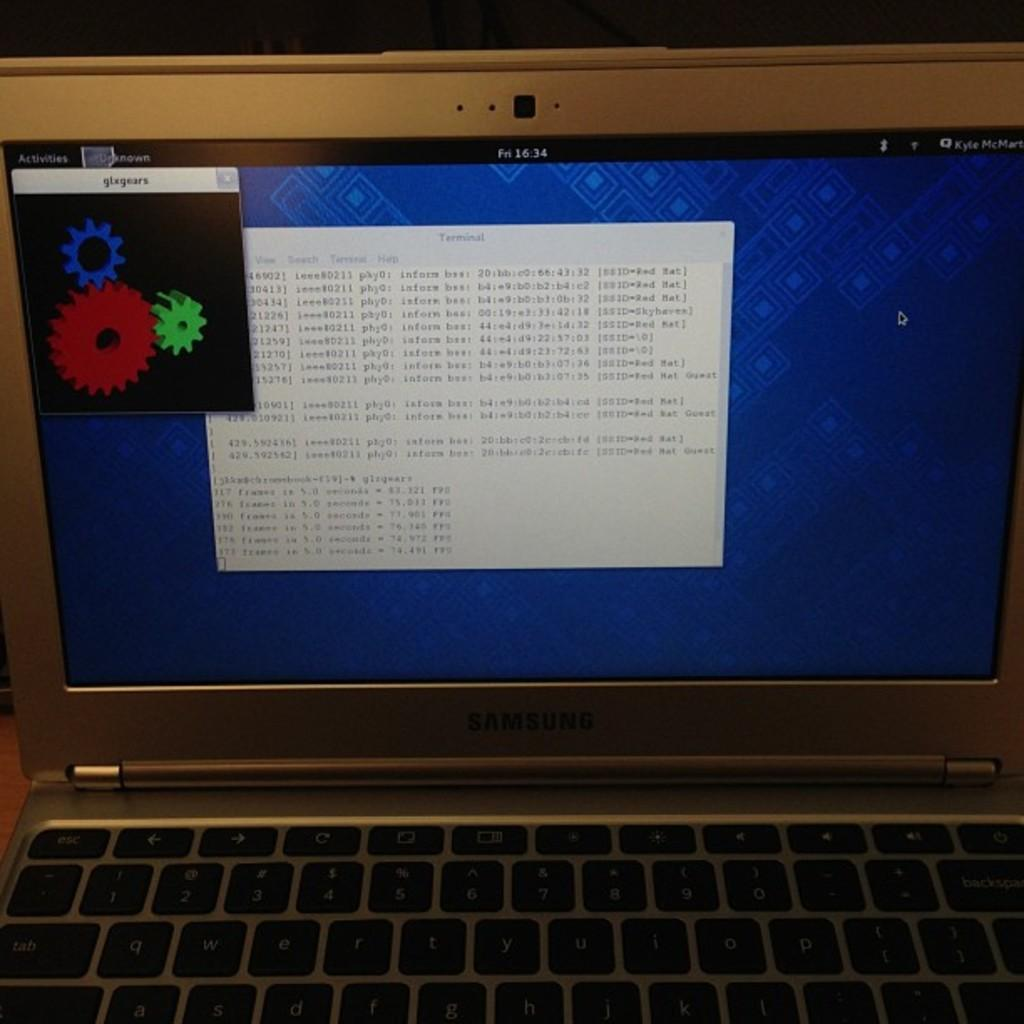<image>
Relay a brief, clear account of the picture shown. A computer screen has a  popup window from glxgears on it. 